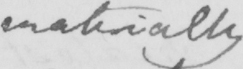Please transcribe the handwritten text in this image. materially 